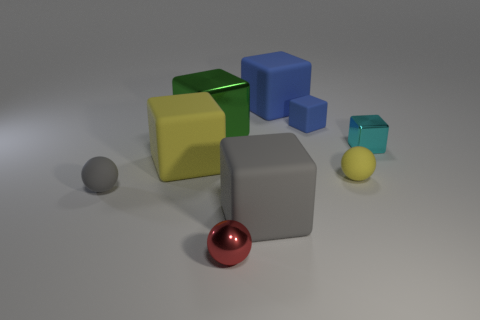How does the lighting affect the mood or feel of the image? The soft lighting in the image casts gentle shadows and gives the scene a calm, serene ambience. It creates a sense of depth and dimension, highlighting the textures and the reflective properties of the objects, which contributes to a feeling of stillness and contemplation.  Can you describe the size relationship between the objects? Certainly. The objects in the image vary in size which seems to follow a descending order, with the largest being the yellow cube and the smallest being the red sphere. This size differentiation, along with the spatial arrangement of the objects, conveys a sense of perspective and depth within the image. 